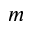Convert formula to latex. <formula><loc_0><loc_0><loc_500><loc_500>m</formula> 